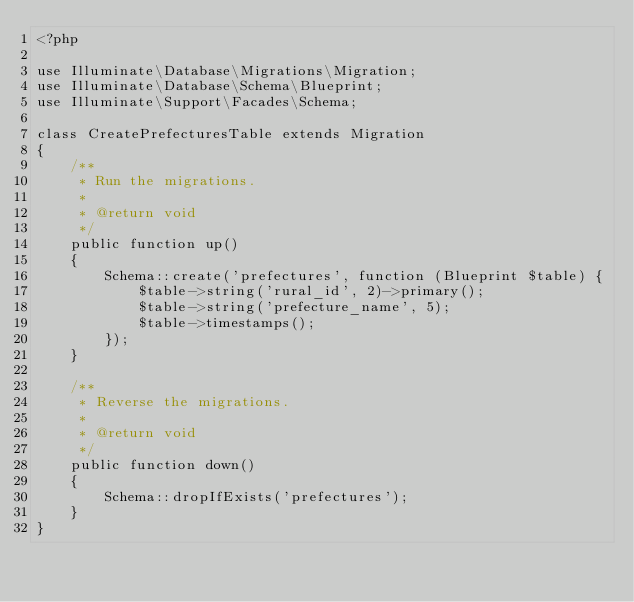<code> <loc_0><loc_0><loc_500><loc_500><_PHP_><?php

use Illuminate\Database\Migrations\Migration;
use Illuminate\Database\Schema\Blueprint;
use Illuminate\Support\Facades\Schema;

class CreatePrefecturesTable extends Migration
{
    /**
     * Run the migrations.
     *
     * @return void
     */
    public function up()
    {
        Schema::create('prefectures', function (Blueprint $table) {
            $table->string('rural_id', 2)->primary();
            $table->string('prefecture_name', 5);
            $table->timestamps();
        });
    }

    /**
     * Reverse the migrations.
     *
     * @return void
     */
    public function down()
    {
        Schema::dropIfExists('prefectures');
    }
}
</code> 